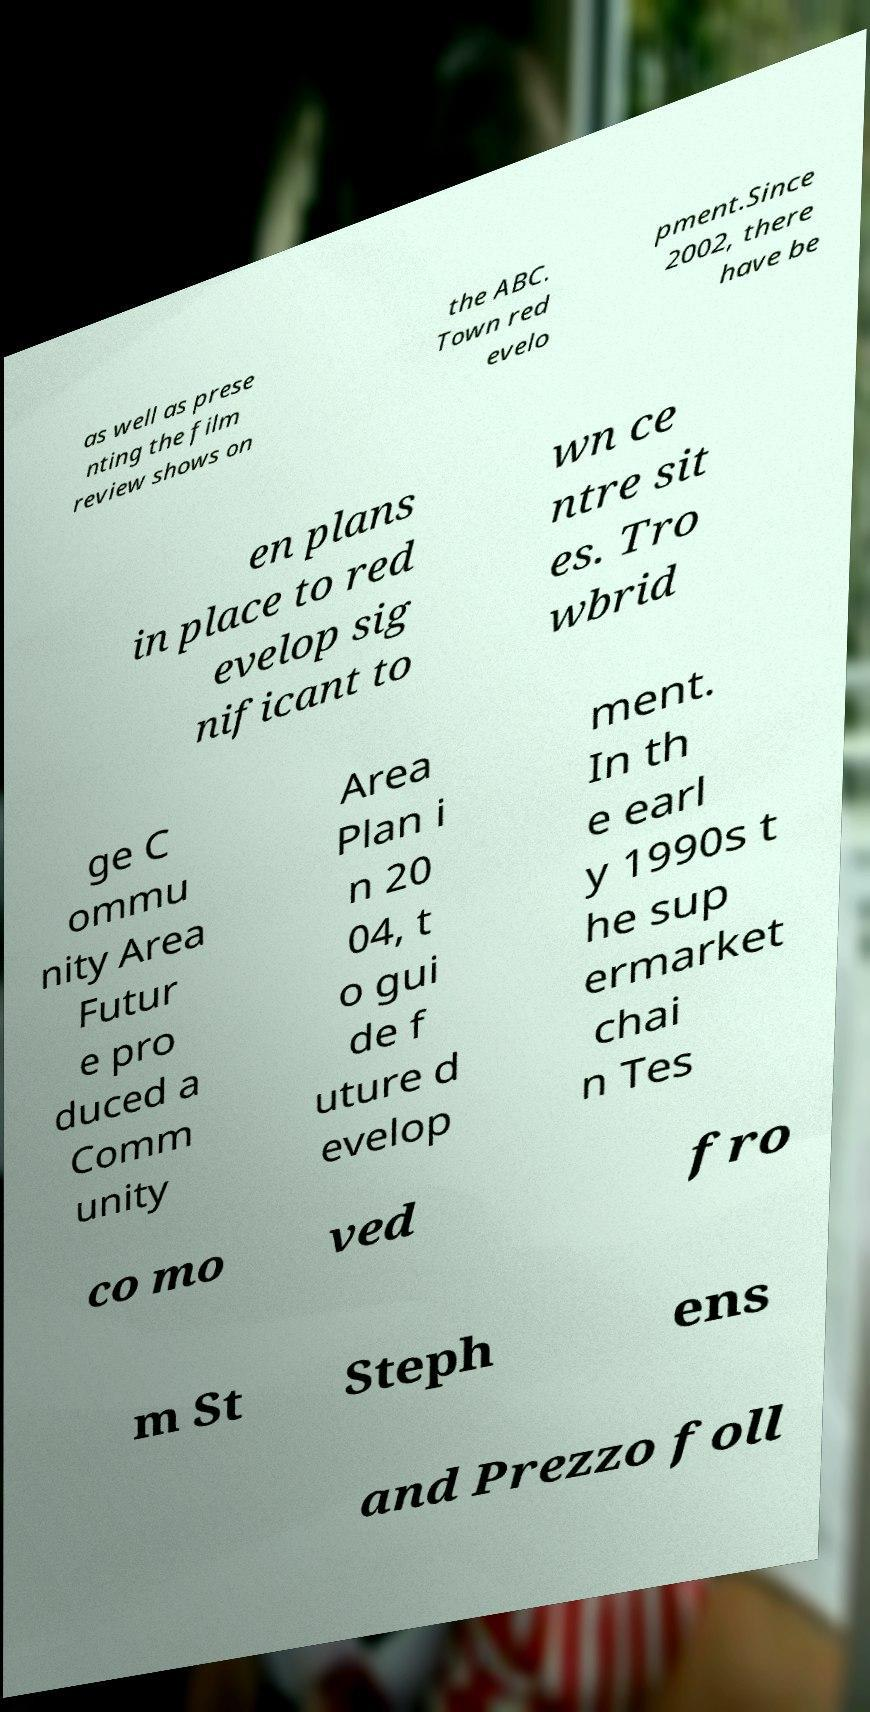Please identify and transcribe the text found in this image. as well as prese nting the film review shows on the ABC. Town red evelo pment.Since 2002, there have be en plans in place to red evelop sig nificant to wn ce ntre sit es. Tro wbrid ge C ommu nity Area Futur e pro duced a Comm unity Area Plan i n 20 04, t o gui de f uture d evelop ment. In th e earl y 1990s t he sup ermarket chai n Tes co mo ved fro m St Steph ens and Prezzo foll 